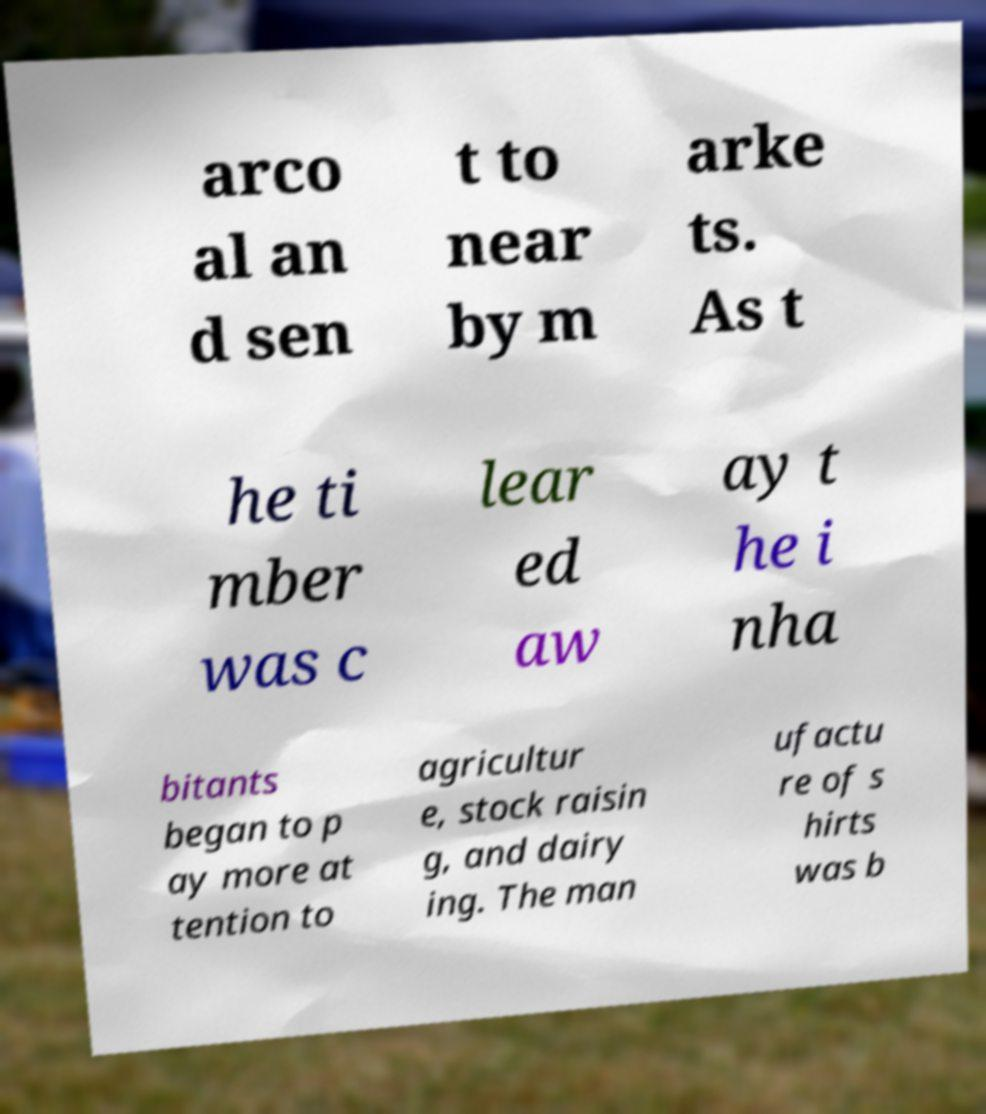I need the written content from this picture converted into text. Can you do that? arco al an d sen t to near by m arke ts. As t he ti mber was c lear ed aw ay t he i nha bitants began to p ay more at tention to agricultur e, stock raisin g, and dairy ing. The man ufactu re of s hirts was b 